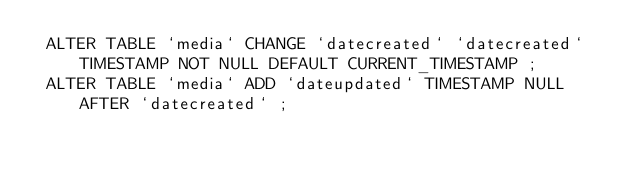Convert code to text. <code><loc_0><loc_0><loc_500><loc_500><_SQL_> ALTER TABLE `media` CHANGE `datecreated` `datecreated` TIMESTAMP NOT NULL DEFAULT CURRENT_TIMESTAMP ;
 ALTER TABLE `media` ADD `dateupdated` TIMESTAMP NULL AFTER `datecreated` ;</code> 